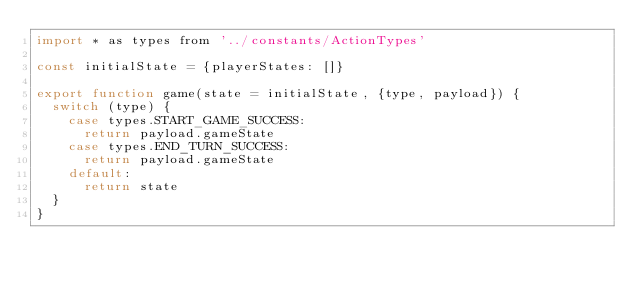Convert code to text. <code><loc_0><loc_0><loc_500><loc_500><_JavaScript_>import * as types from '../constants/ActionTypes'

const initialState = {playerStates: []}

export function game(state = initialState, {type, payload}) {
  switch (type) {
    case types.START_GAME_SUCCESS:
      return payload.gameState
    case types.END_TURN_SUCCESS:
      return payload.gameState
    default:
      return state
  }
}
</code> 